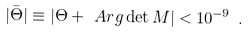Convert formula to latex. <formula><loc_0><loc_0><loc_500><loc_500>| \bar { \Theta } | \equiv | \Theta + \ A r g \det M | < 1 0 ^ { - 9 } \ .</formula> 